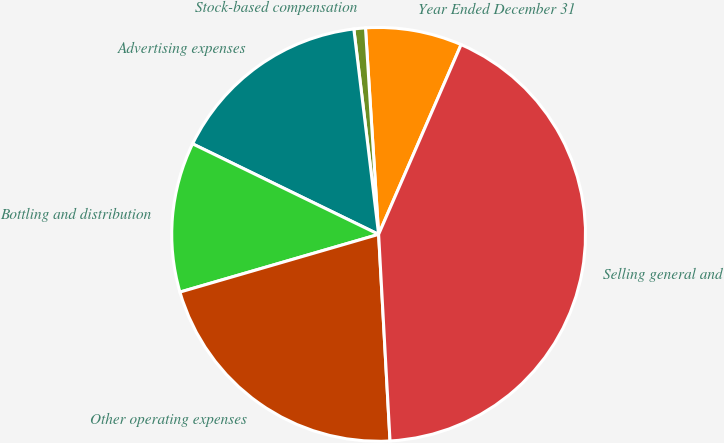<chart> <loc_0><loc_0><loc_500><loc_500><pie_chart><fcel>Year Ended December 31<fcel>Stock-based compensation<fcel>Advertising expenses<fcel>Bottling and distribution<fcel>Other operating expenses<fcel>Selling general and<nl><fcel>7.54%<fcel>0.9%<fcel>15.88%<fcel>11.71%<fcel>21.38%<fcel>42.6%<nl></chart> 